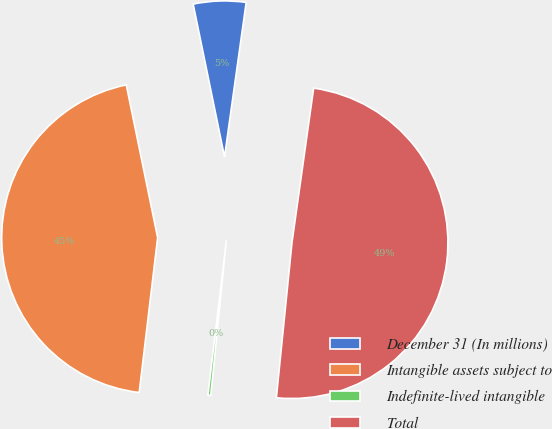Convert chart to OTSL. <chart><loc_0><loc_0><loc_500><loc_500><pie_chart><fcel>December 31 (In millions)<fcel>Intangible assets subject to<fcel>Indefinite-lived intangible<fcel>Total<nl><fcel>5.44%<fcel>44.89%<fcel>0.29%<fcel>49.38%<nl></chart> 